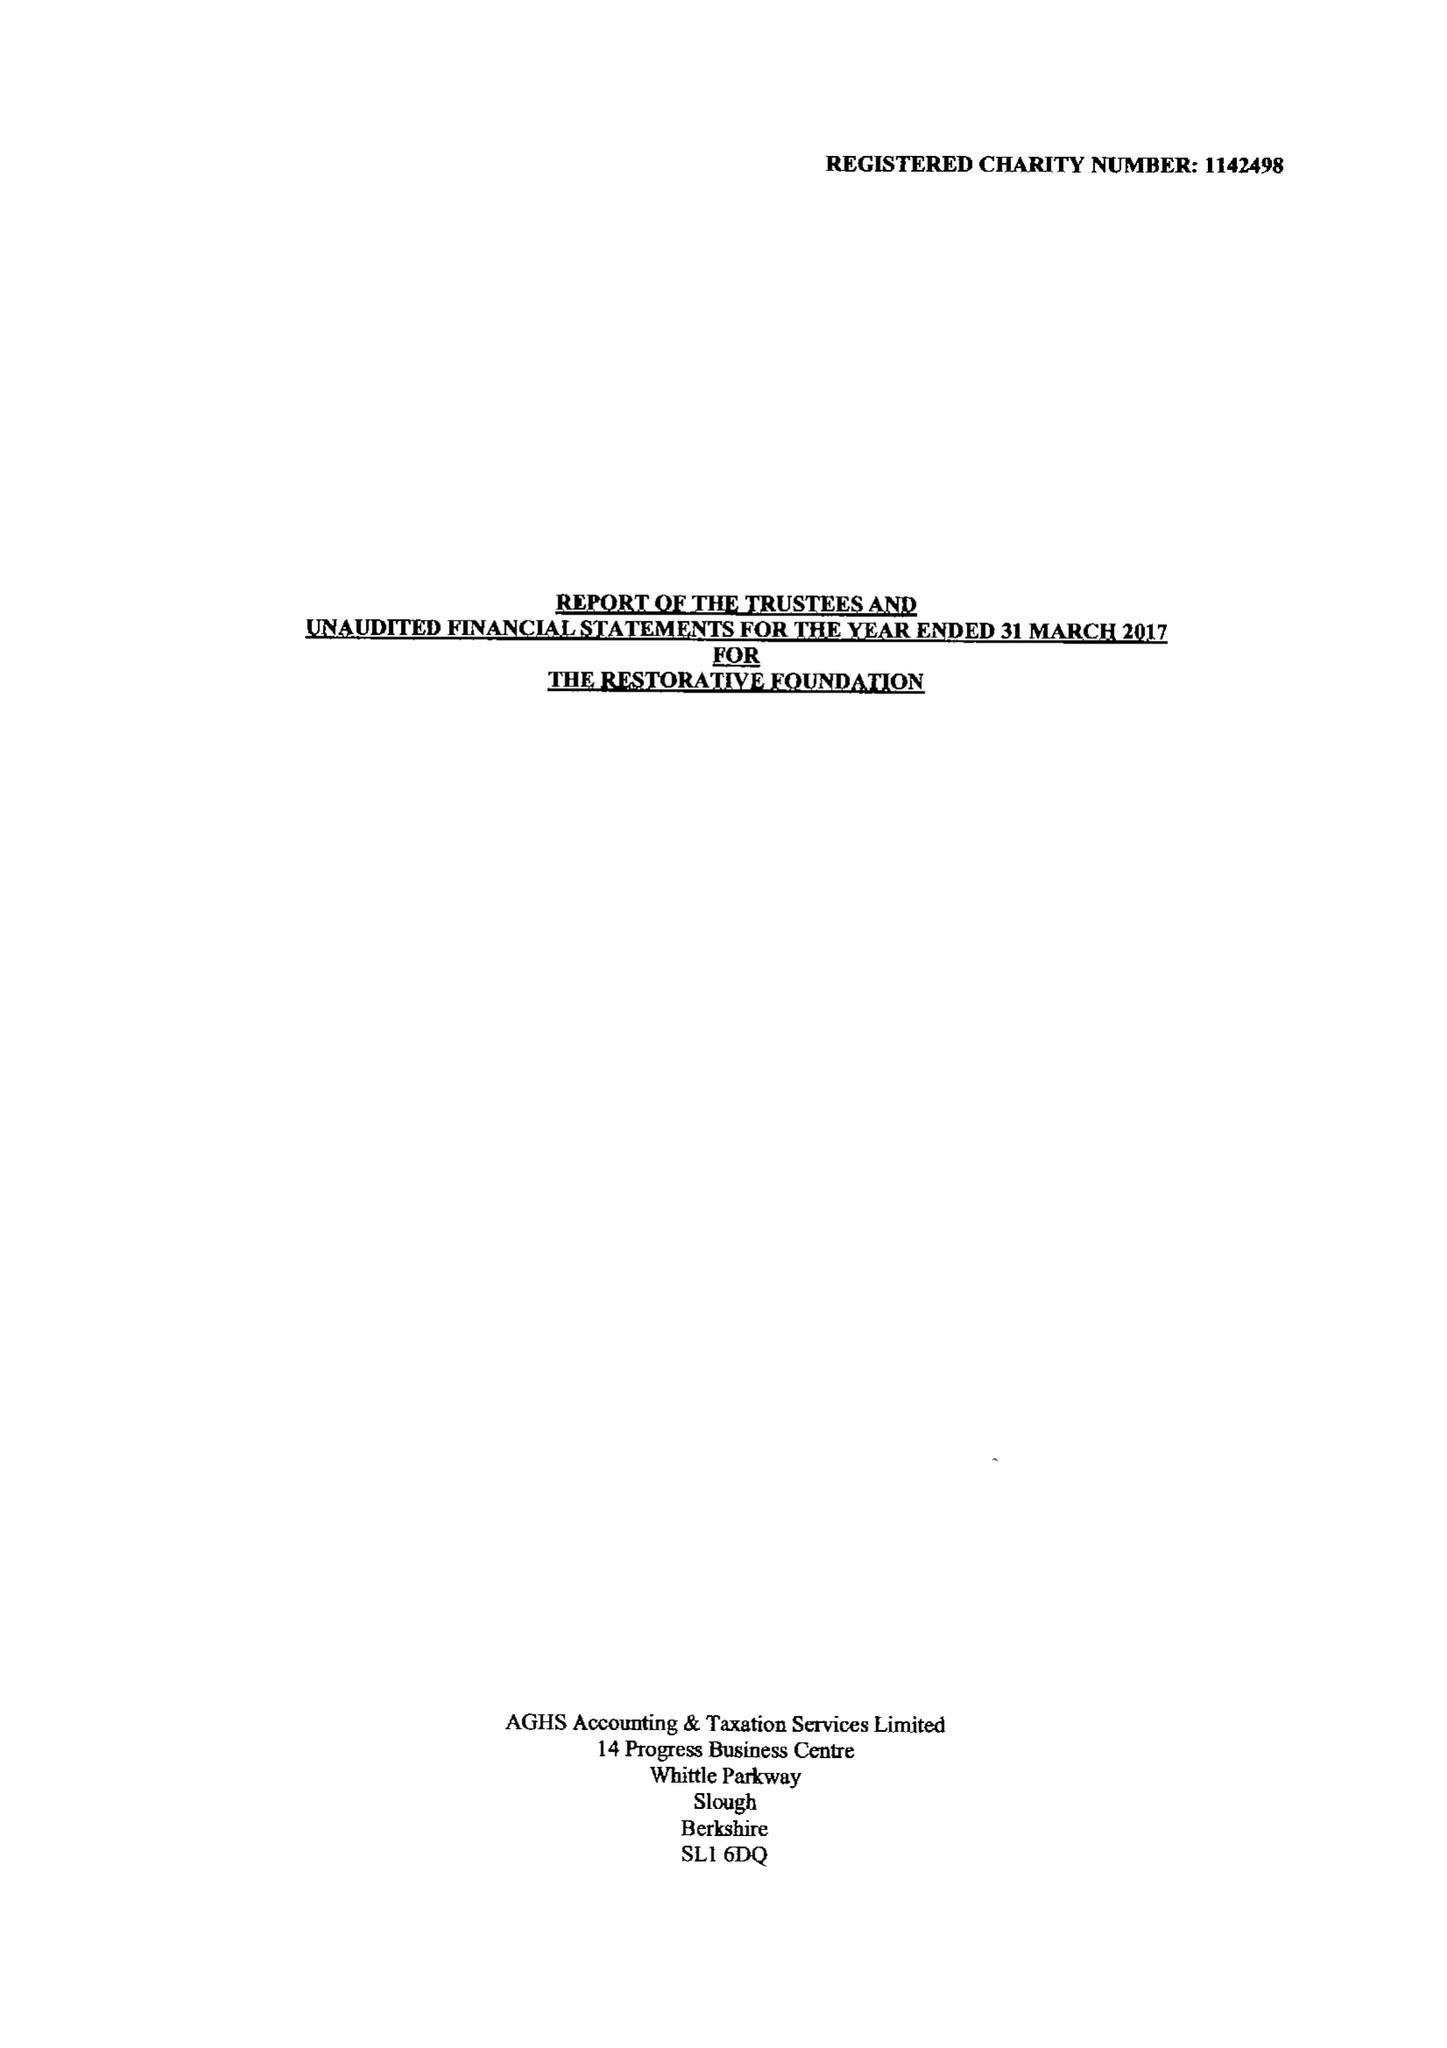What is the value for the charity_name?
Answer the question using a single word or phrase. The Restorative Foundation 